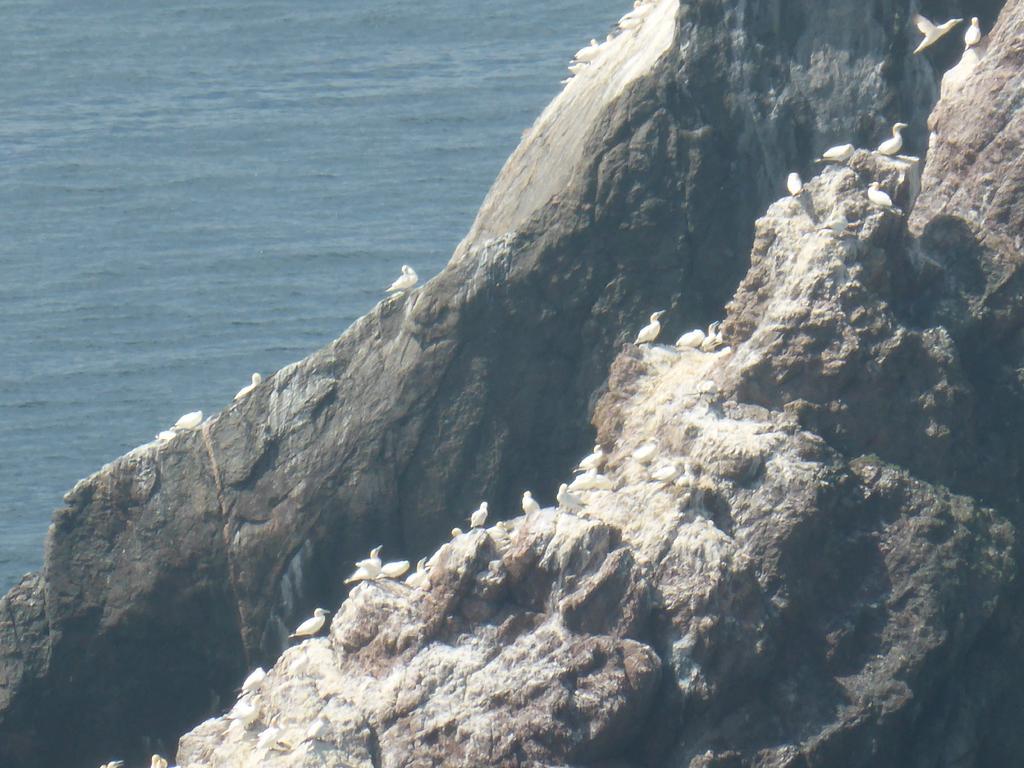Please provide a concise description of this image. In this picture we can see birds on the rock hills. In the top right corner of the picture can see a bird flying. In the background we can see water. 